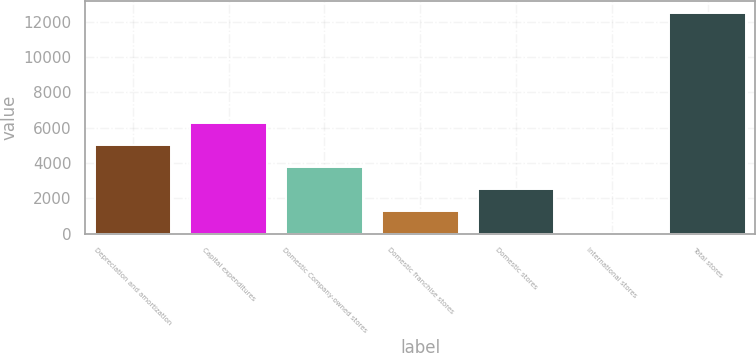<chart> <loc_0><loc_0><loc_500><loc_500><bar_chart><fcel>Depreciation and amortization<fcel>Capital expenditures<fcel>Domestic Company-owned stores<fcel>Domestic franchise stores<fcel>Domestic stores<fcel>International stores<fcel>Total stores<nl><fcel>5016.68<fcel>6268.9<fcel>3764.46<fcel>1260.02<fcel>2512.24<fcel>7.8<fcel>12530<nl></chart> 